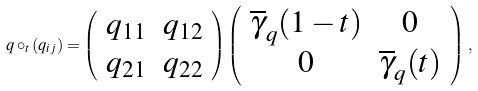Convert formula to latex. <formula><loc_0><loc_0><loc_500><loc_500>q \circ _ { t } \left ( q _ { i j } \right ) = \left ( \begin{array} { c c } q _ { 1 1 } & q _ { 1 2 } \\ q _ { 2 1 } & q _ { 2 2 } \end{array} \right ) \left ( \begin{array} { c c } \overline { \gamma } _ { q } ( 1 - t ) & 0 \\ 0 & \overline { \gamma } _ { q } ( t ) \end{array} \right ) \, ,</formula> 